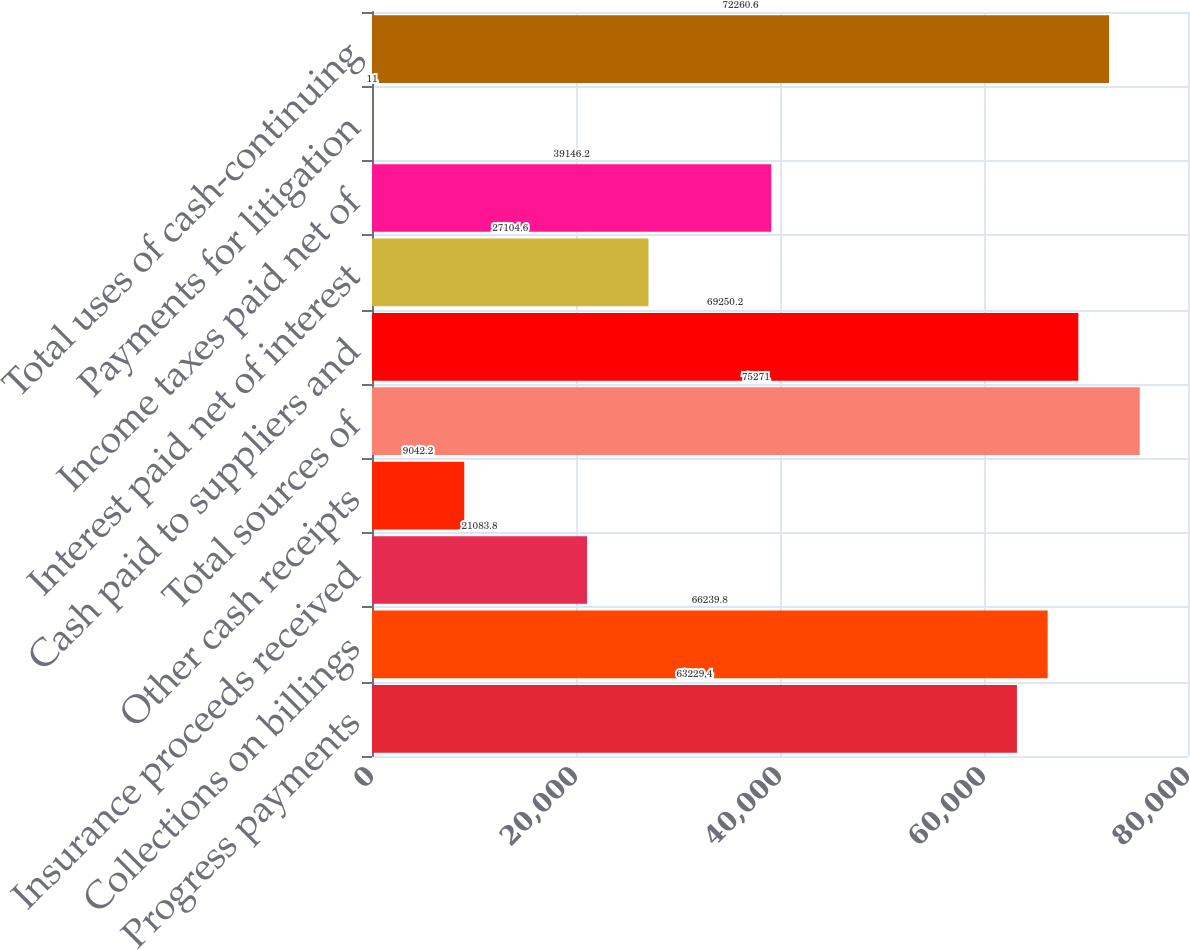Convert chart to OTSL. <chart><loc_0><loc_0><loc_500><loc_500><bar_chart><fcel>Progress payments<fcel>Collections on billings<fcel>Insurance proceeds received<fcel>Other cash receipts<fcel>Total sources of<fcel>Cash paid to suppliers and<fcel>Interest paid net of interest<fcel>Income taxes paid net of<fcel>Payments for litigation<fcel>Total uses of cash-continuing<nl><fcel>63229.4<fcel>66239.8<fcel>21083.8<fcel>9042.2<fcel>75271<fcel>69250.2<fcel>27104.6<fcel>39146.2<fcel>11<fcel>72260.6<nl></chart> 